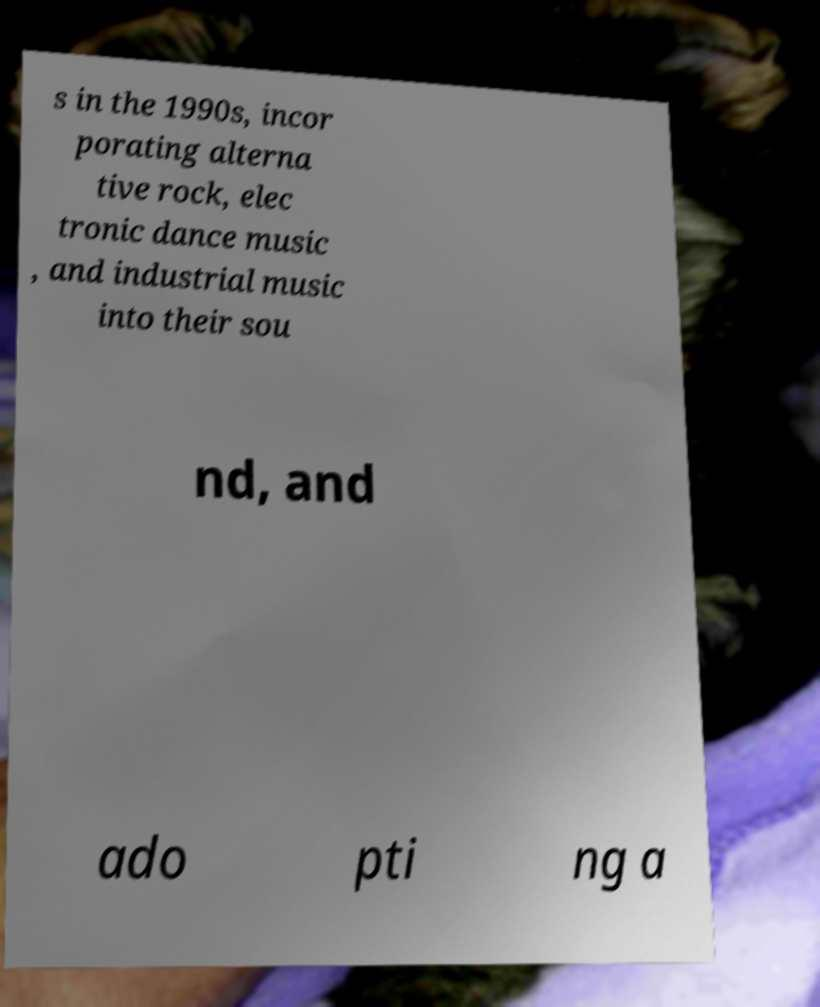Can you read and provide the text displayed in the image?This photo seems to have some interesting text. Can you extract and type it out for me? s in the 1990s, incor porating alterna tive rock, elec tronic dance music , and industrial music into their sou nd, and ado pti ng a 